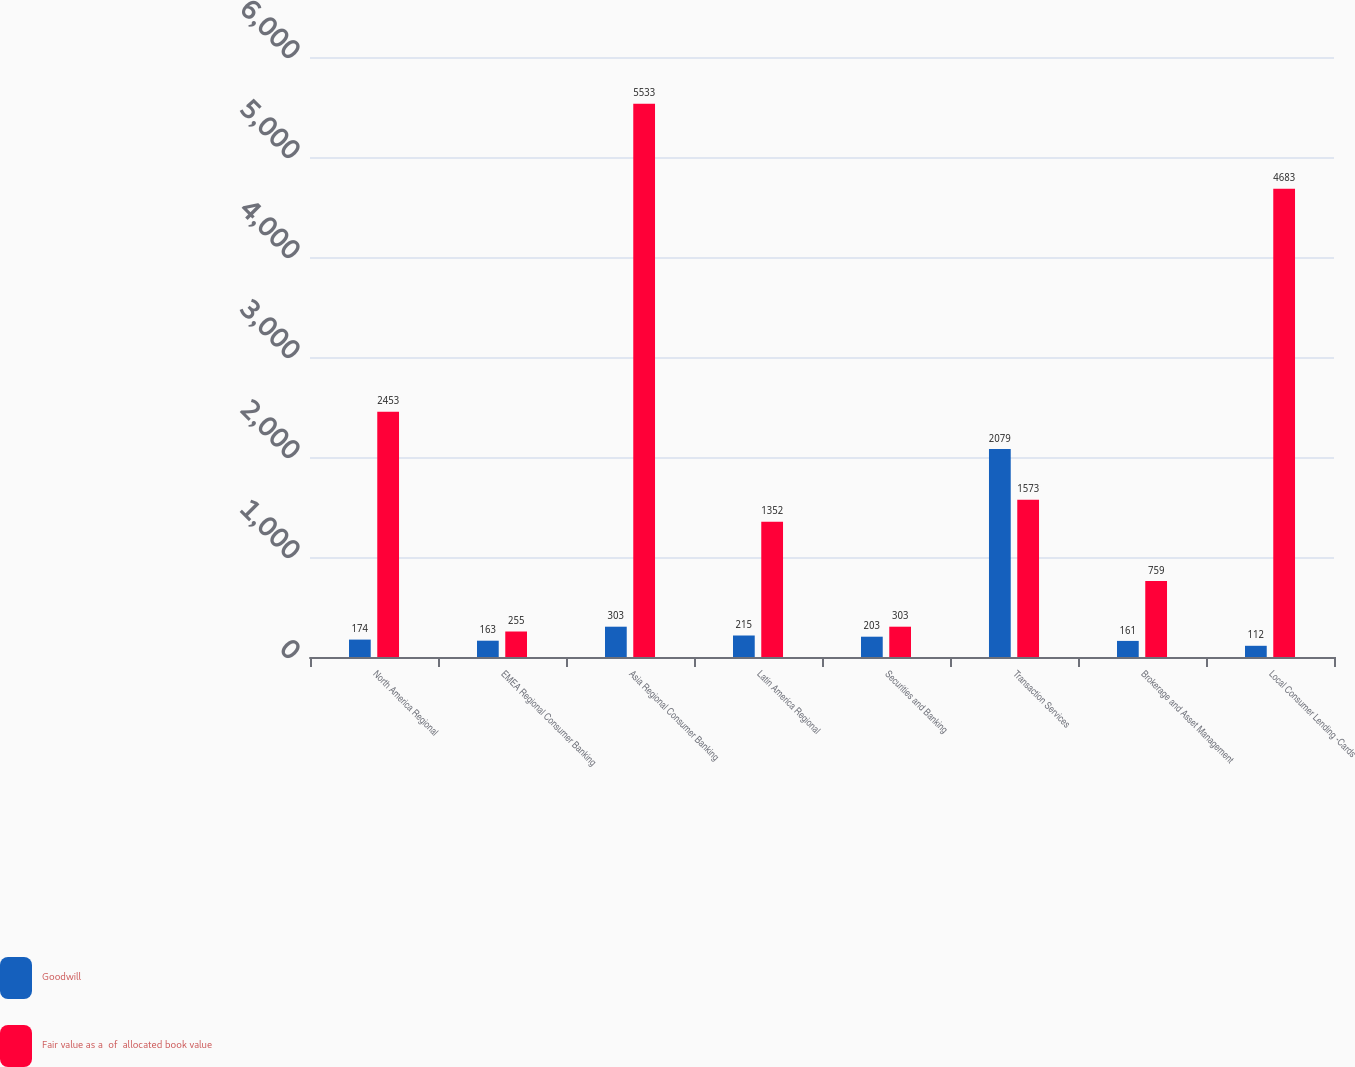Convert chart to OTSL. <chart><loc_0><loc_0><loc_500><loc_500><stacked_bar_chart><ecel><fcel>North America Regional<fcel>EMEA Regional Consumer Banking<fcel>Asia Regional Consumer Banking<fcel>Latin America Regional<fcel>Securities and Banking<fcel>Transaction Services<fcel>Brokerage and Asset Management<fcel>Local Consumer Lending -Cards<nl><fcel>Goodwill<fcel>174<fcel>163<fcel>303<fcel>215<fcel>203<fcel>2079<fcel>161<fcel>112<nl><fcel>Fair value as a  of  allocated book value<fcel>2453<fcel>255<fcel>5533<fcel>1352<fcel>303<fcel>1573<fcel>759<fcel>4683<nl></chart> 